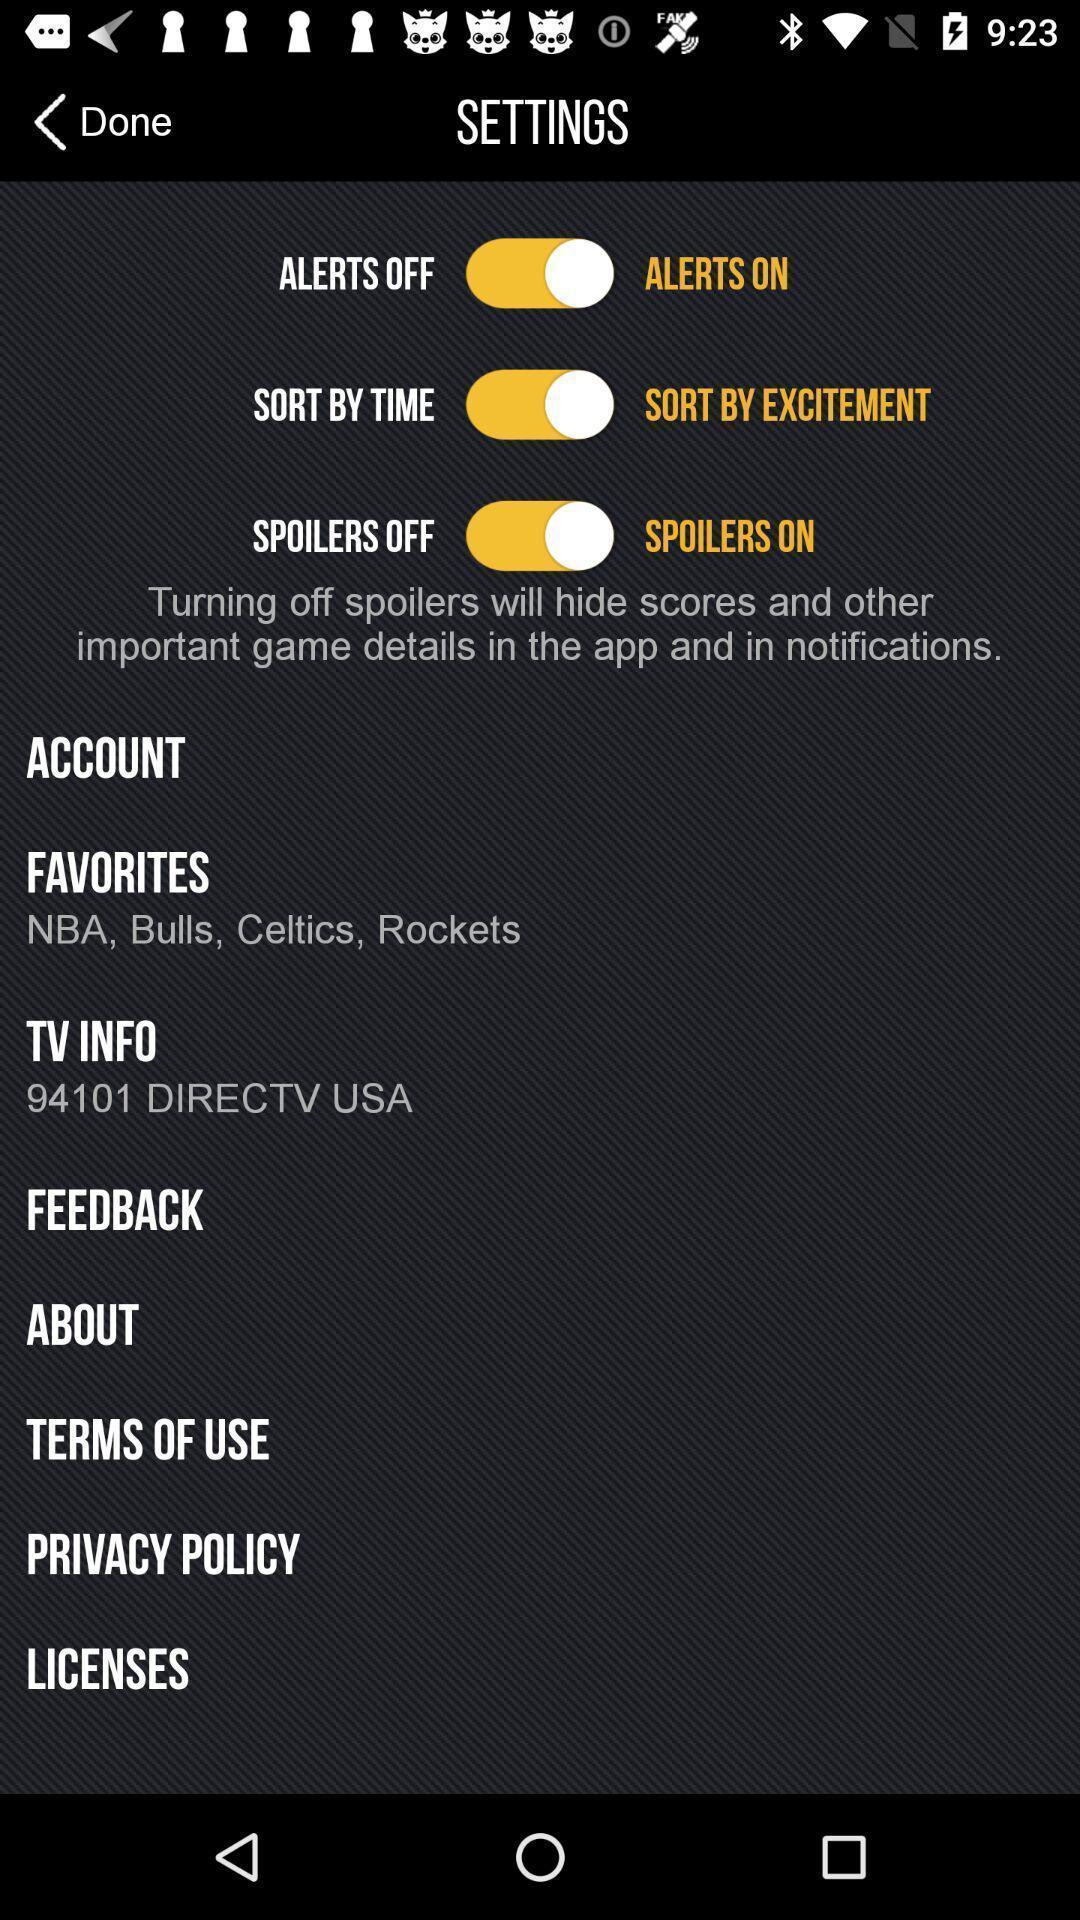What details can you identify in this image? Settings page. 